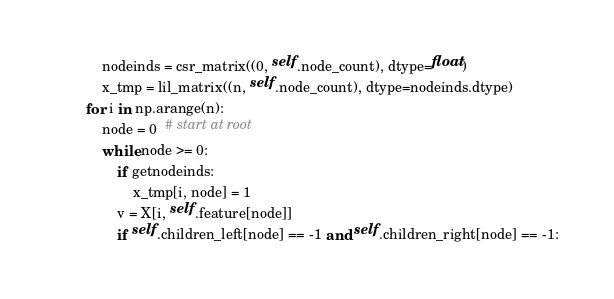Convert code to text. <code><loc_0><loc_0><loc_500><loc_500><_Python_>            nodeinds = csr_matrix((0, self.node_count), dtype=float)
            x_tmp = lil_matrix((n, self.node_count), dtype=nodeinds.dtype)
        for i in np.arange(n):
            node = 0  # start at root
            while node >= 0:
                if getnodeinds:
                    x_tmp[i, node] = 1
                v = X[i, self.feature[node]]
                if self.children_left[node] == -1 and self.children_right[node] == -1:</code> 